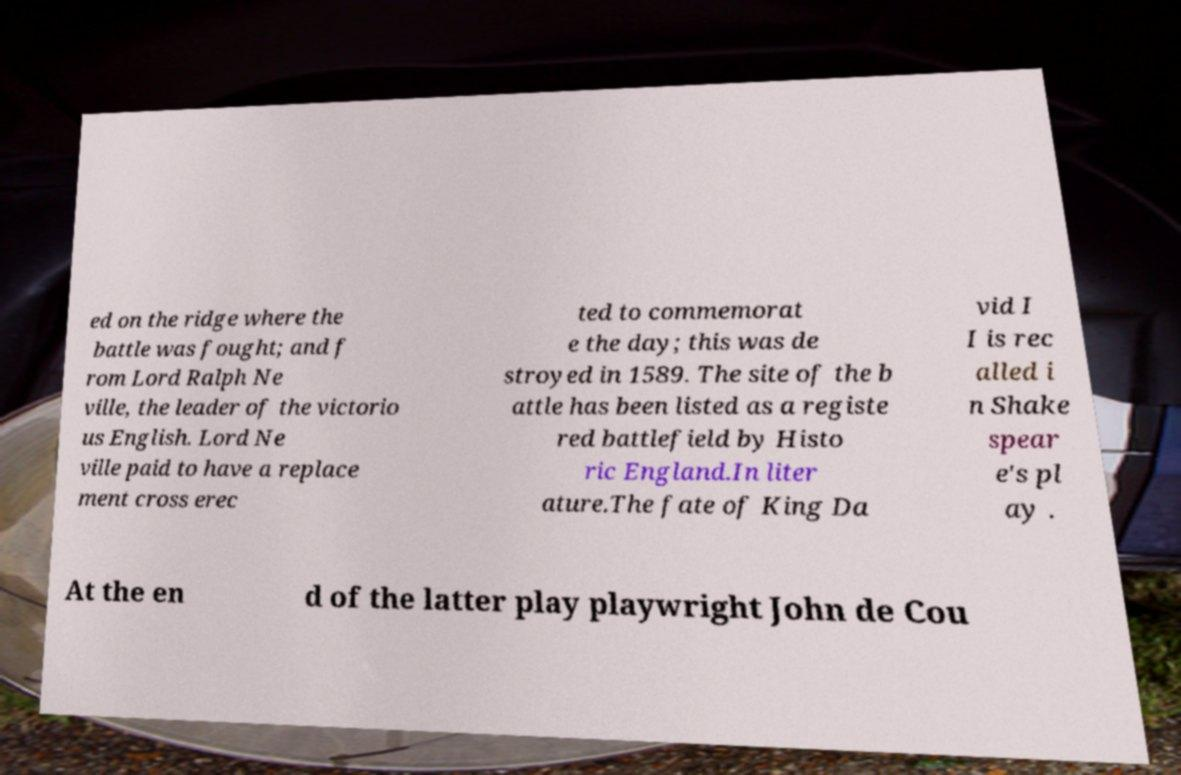Please identify and transcribe the text found in this image. ed on the ridge where the battle was fought; and f rom Lord Ralph Ne ville, the leader of the victorio us English. Lord Ne ville paid to have a replace ment cross erec ted to commemorat e the day; this was de stroyed in 1589. The site of the b attle has been listed as a registe red battlefield by Histo ric England.In liter ature.The fate of King Da vid I I is rec alled i n Shake spear e's pl ay . At the en d of the latter play playwright John de Cou 